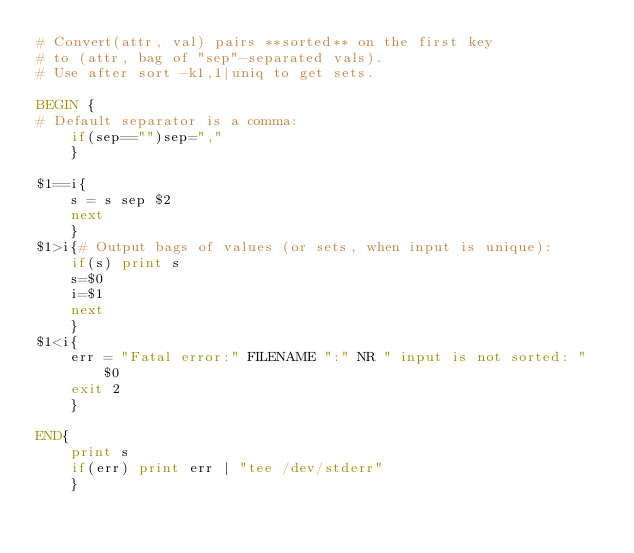<code> <loc_0><loc_0><loc_500><loc_500><_Awk_># Convert(attr, val) pairs **sorted** on the first key 
# to (attr, bag of "sep"-separated vals). 
# Use after sort -k1,1|uniq to get sets.

BEGIN {
# Default separator is a comma:
    if(sep=="")sep=","
    }

$1==i{
    s = s sep $2
    next
    }
$1>i{# Output bags of values (or sets, when input is unique):
    if(s) print s
    s=$0
    i=$1
    next
    }
$1<i{
    err = "Fatal error:" FILENAME ":" NR " input is not sorted: " $0
    exit 2
    }

END{
    print s
    if(err) print err | "tee /dev/stderr"
    }
</code> 